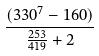Convert formula to latex. <formula><loc_0><loc_0><loc_500><loc_500>\frac { ( 3 3 0 ^ { 7 } - 1 6 0 ) } { \frac { 2 5 3 } { 4 1 9 } + 2 }</formula> 